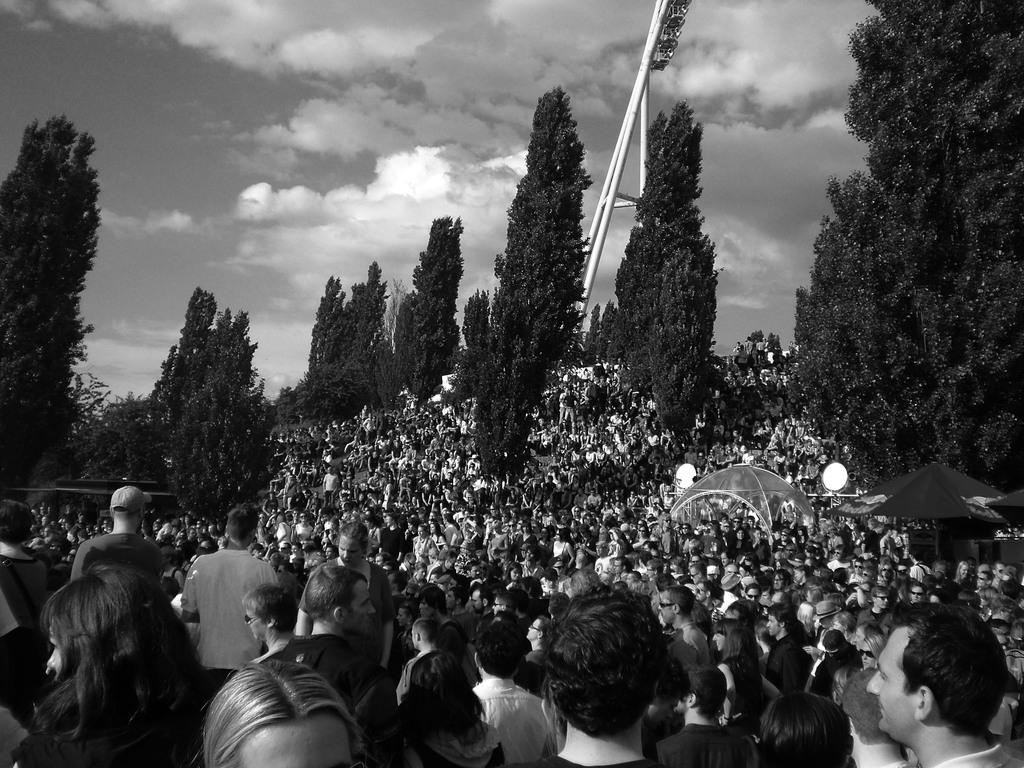What is present on the ground in the image? There are persons and trees on the ground in the image. Can you describe the vegetation in the image? There are trees on the ground in the image. What can be seen in the sky in the background? There are clouds in the sky in the background. What type of coil can be seen in the image? There is no coil present in the image. What is the aftermath of the event in the image? There is no event or aftermath depicted in the image; it shows persons and trees on the ground with clouds in the sky. 